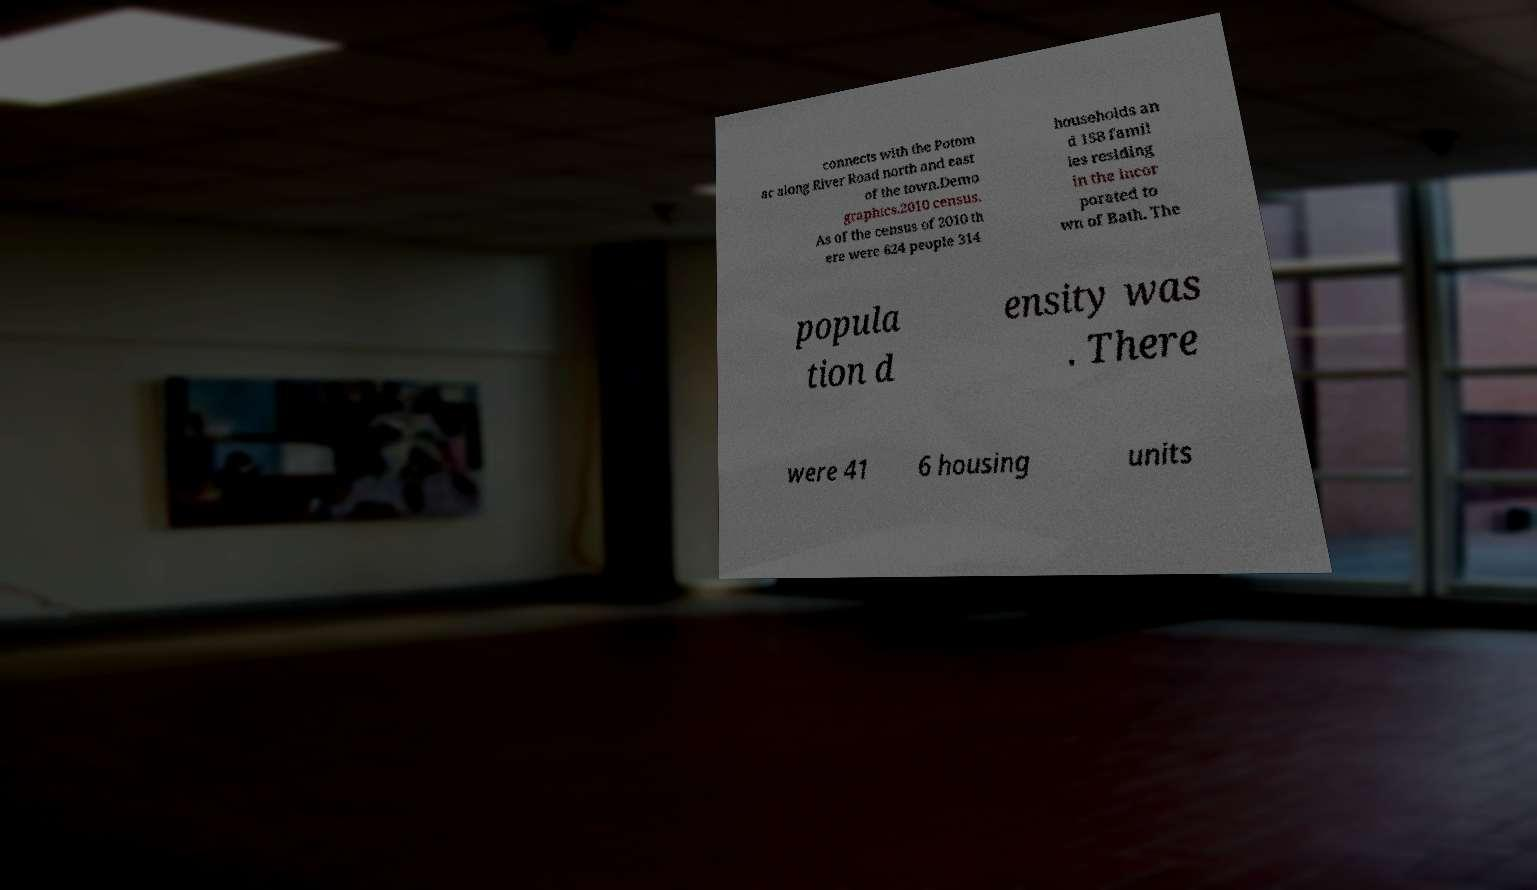There's text embedded in this image that I need extracted. Can you transcribe it verbatim? connects with the Potom ac along River Road north and east of the town.Demo graphics.2010 census. As of the census of 2010 th ere were 624 people 314 households an d 158 famil ies residing in the incor porated to wn of Bath. The popula tion d ensity was . There were 41 6 housing units 